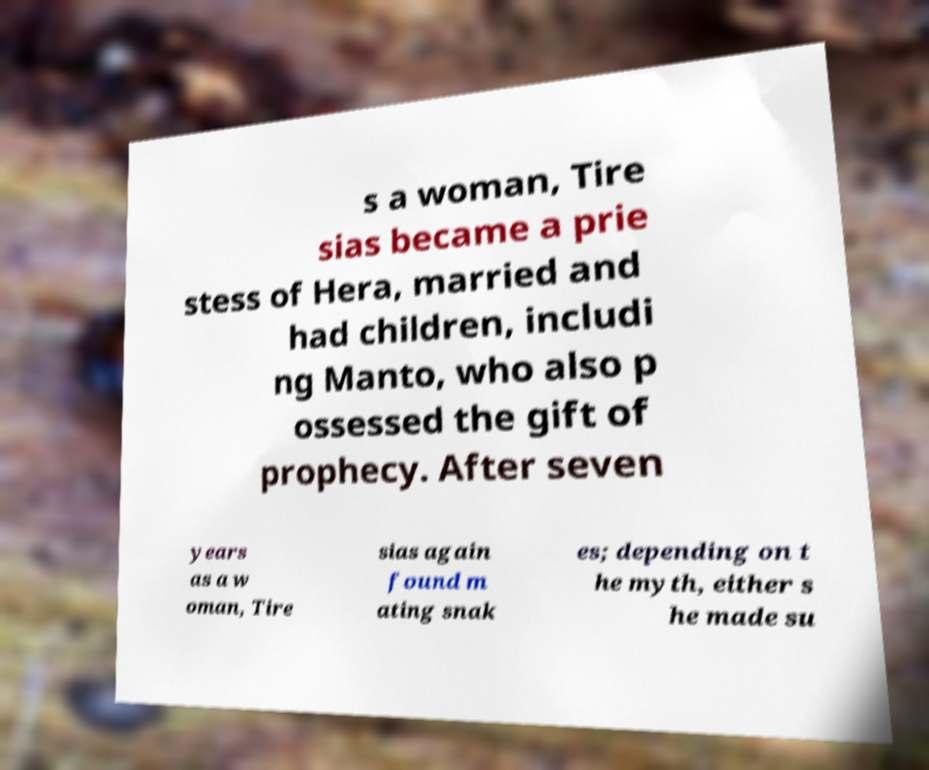I need the written content from this picture converted into text. Can you do that? s a woman, Tire sias became a prie stess of Hera, married and had children, includi ng Manto, who also p ossessed the gift of prophecy. After seven years as a w oman, Tire sias again found m ating snak es; depending on t he myth, either s he made su 